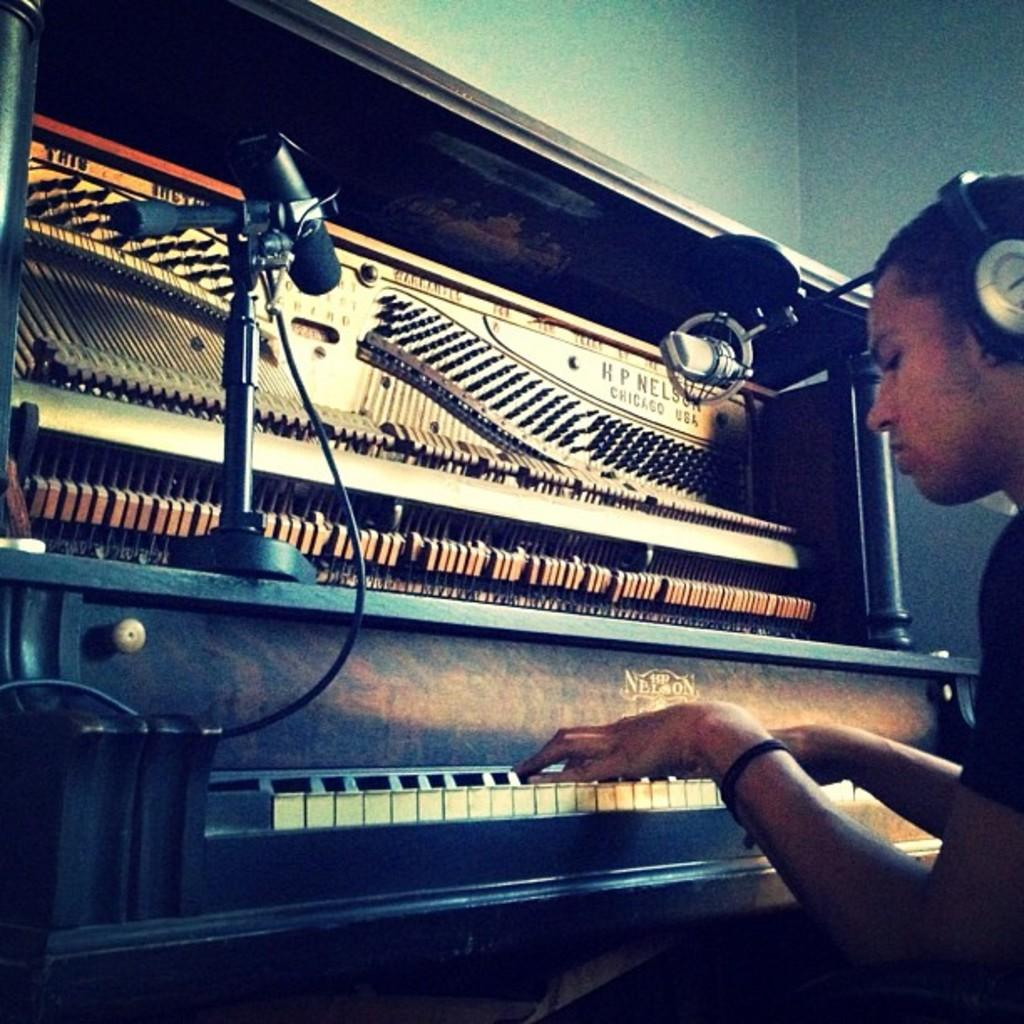What is the person in the image doing? The person is playing a piano. What object is on the piano? There is a microphone on the piano. What might the person be using to listen to the music? The person is wearing headphones. What sign can be seen on the truck in the image? There is no truck present in the image; it only features a person playing a piano with a microphone and headphones. 